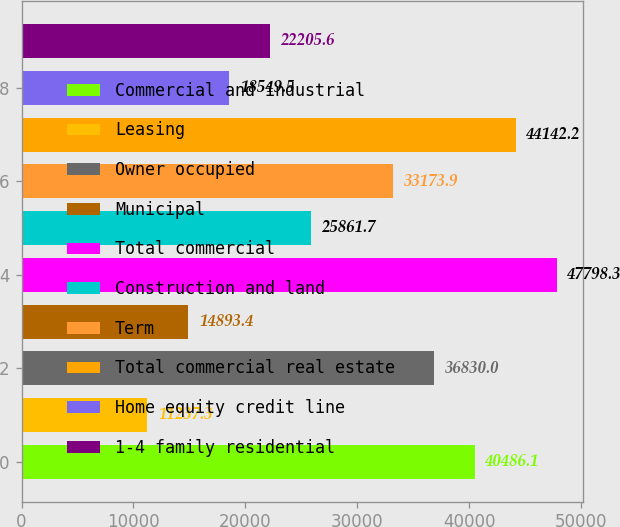Convert chart. <chart><loc_0><loc_0><loc_500><loc_500><bar_chart><fcel>Commercial and industrial<fcel>Leasing<fcel>Owner occupied<fcel>Municipal<fcel>Total commercial<fcel>Construction and land<fcel>Term<fcel>Total commercial real estate<fcel>Home equity credit line<fcel>1-4 family residential<nl><fcel>40486.1<fcel>11237.3<fcel>36830<fcel>14893.4<fcel>47798.3<fcel>25861.7<fcel>33173.9<fcel>44142.2<fcel>18549.5<fcel>22205.6<nl></chart> 